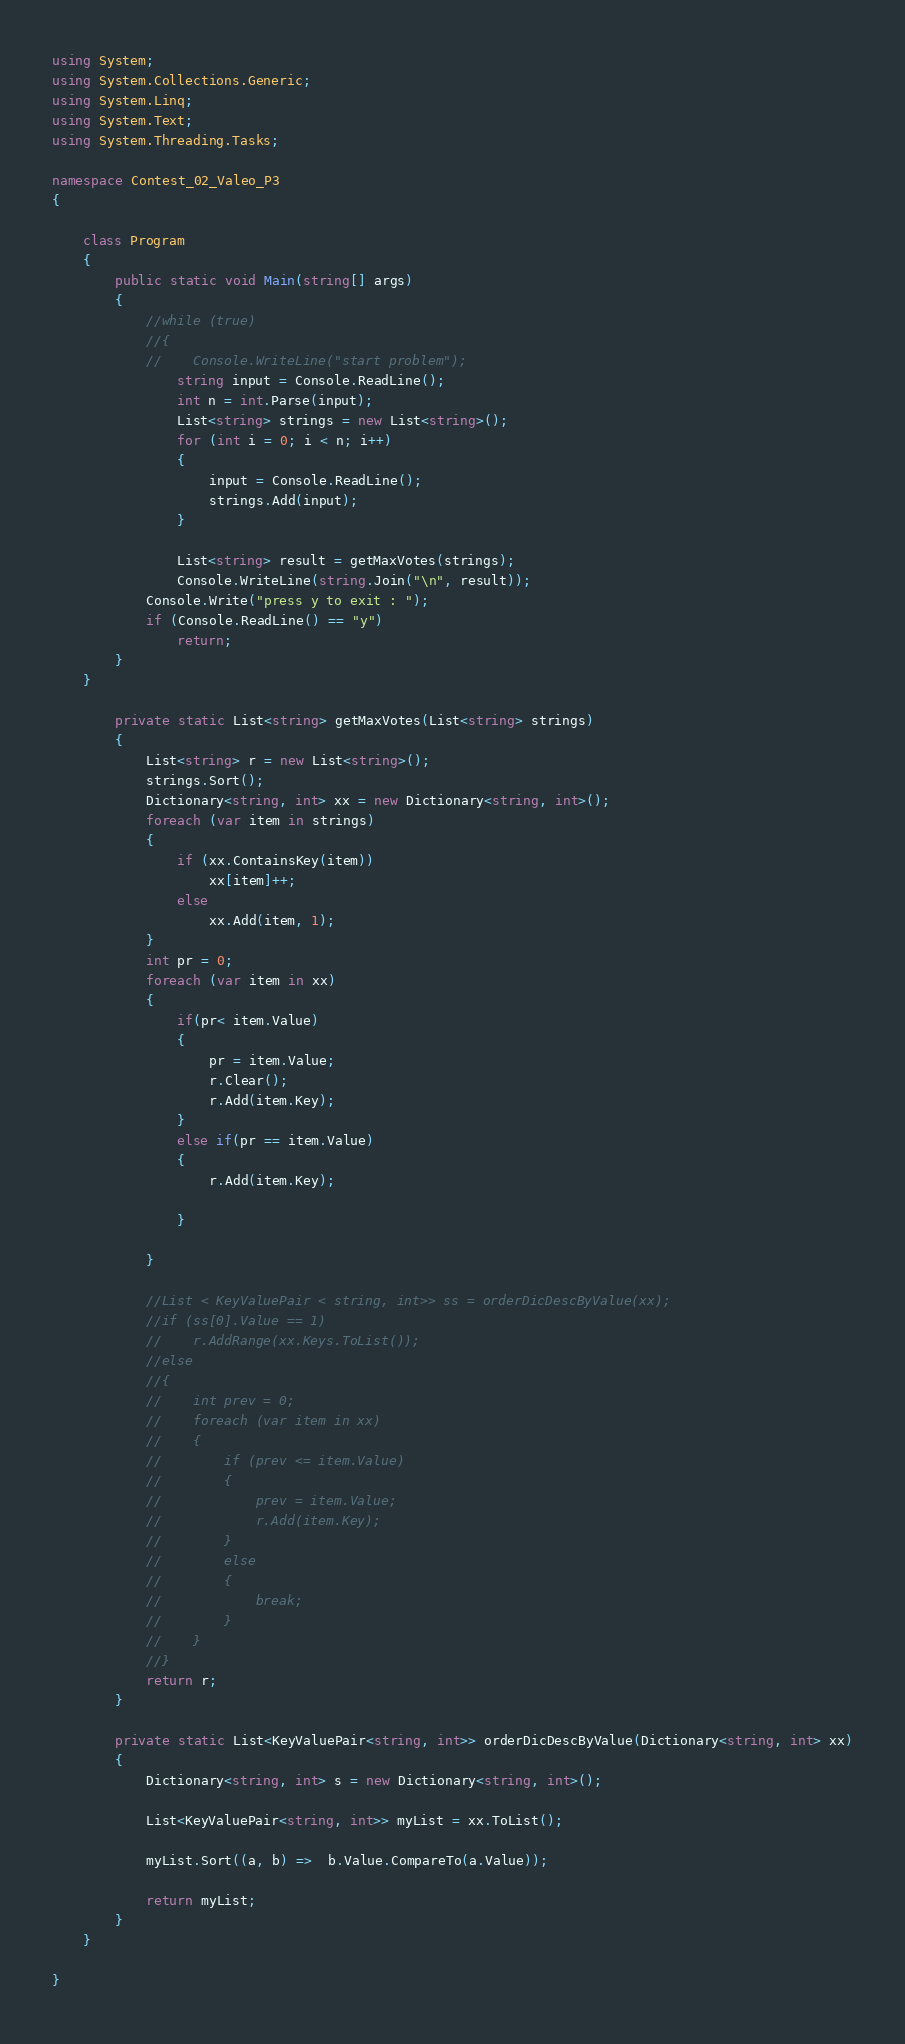Convert code to text. <code><loc_0><loc_0><loc_500><loc_500><_C#_>using System;
using System.Collections.Generic;
using System.Linq;
using System.Text;
using System.Threading.Tasks;

namespace Contest_02_Valeo_P3
{

    class Program
    {
        public static void Main(string[] args)
        {
            //while (true)
            //{
            //    Console.WriteLine("start problem");
                string input = Console.ReadLine();
                int n = int.Parse(input);
                List<string> strings = new List<string>();
                for (int i = 0; i < n; i++)
                {
                    input = Console.ReadLine();
                    strings.Add(input);
                }

                List<string> result = getMaxVotes(strings);
                Console.WriteLine(string.Join("\n", result));
            Console.Write("press y to exit : ");
            if (Console.ReadLine() == "y")
                return;
        }
    }

        private static List<string> getMaxVotes(List<string> strings)
        {
            List<string> r = new List<string>();
            strings.Sort();
            Dictionary<string, int> xx = new Dictionary<string, int>();
            foreach (var item in strings)
            {
                if (xx.ContainsKey(item))
                    xx[item]++;
                else
                    xx.Add(item, 1);
            }
            int pr = 0;
            foreach (var item in xx)
            {
                if(pr< item.Value)
                {
                    pr = item.Value;
                    r.Clear();
                    r.Add(item.Key);
                }
                else if(pr == item.Value)
                {
                    r.Add(item.Key);

                }

            }

            //List < KeyValuePair < string, int>> ss = orderDicDescByValue(xx);
            //if (ss[0].Value == 1)
            //    r.AddRange(xx.Keys.ToList());
            //else
            //{
            //    int prev = 0;
            //    foreach (var item in xx)
            //    {
            //        if (prev <= item.Value)
            //        {
            //            prev = item.Value;
            //            r.Add(item.Key);
            //        }
            //        else
            //        {
            //            break;
            //        }
            //    }
            //}
            return r;
        }

        private static List<KeyValuePair<string, int>> orderDicDescByValue(Dictionary<string, int> xx)
        {
            Dictionary<string, int> s = new Dictionary<string, int>();

            List<KeyValuePair<string, int>> myList = xx.ToList();

            myList.Sort((a, b) =>  b.Value.CompareTo(a.Value));
            
            return myList;
        }
    }
    
}
</code> 